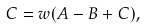Convert formula to latex. <formula><loc_0><loc_0><loc_500><loc_500>C = w ( A - B + C ) ,</formula> 